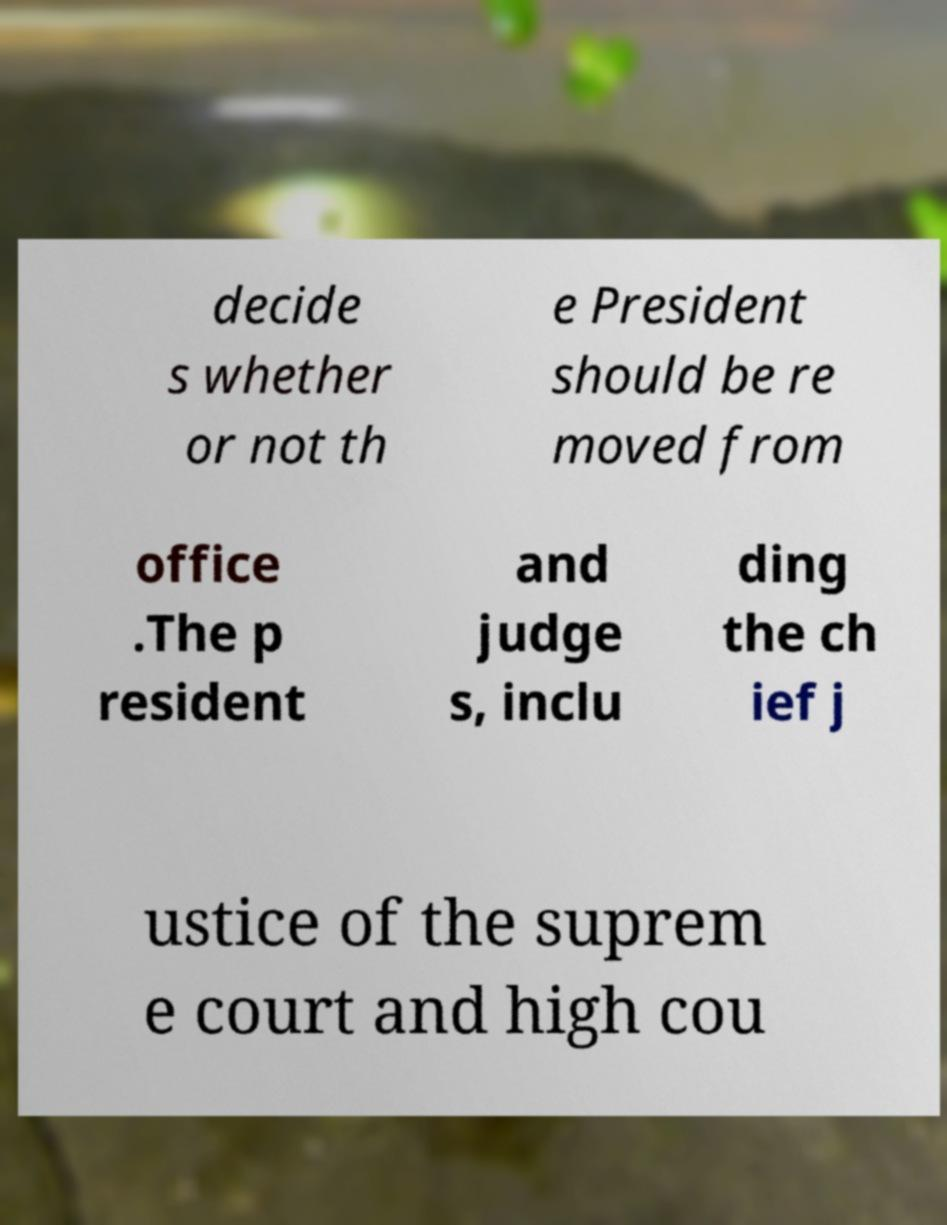Can you read and provide the text displayed in the image?This photo seems to have some interesting text. Can you extract and type it out for me? decide s whether or not th e President should be re moved from office .The p resident and judge s, inclu ding the ch ief j ustice of the suprem e court and high cou 